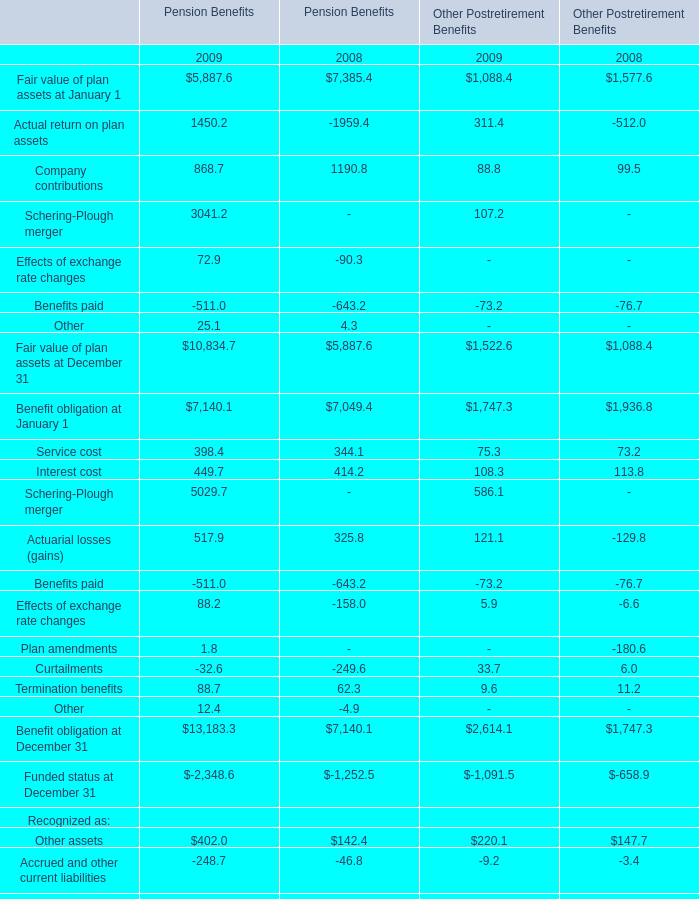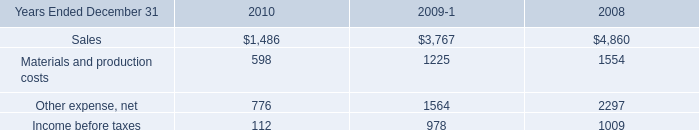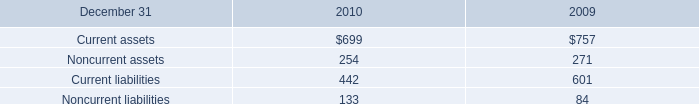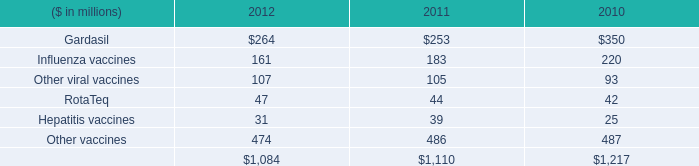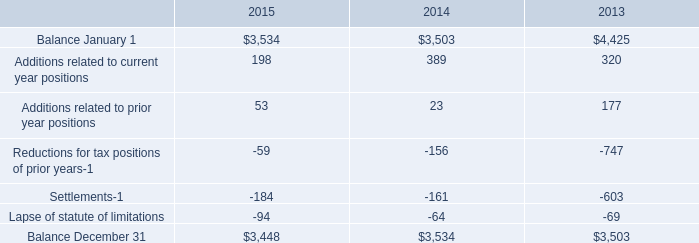What is the difference between the greatest Other for Pension Benefits in 2008 and 2009？ 
Computations: (12.4 - -4.9)
Answer: 17.3. 